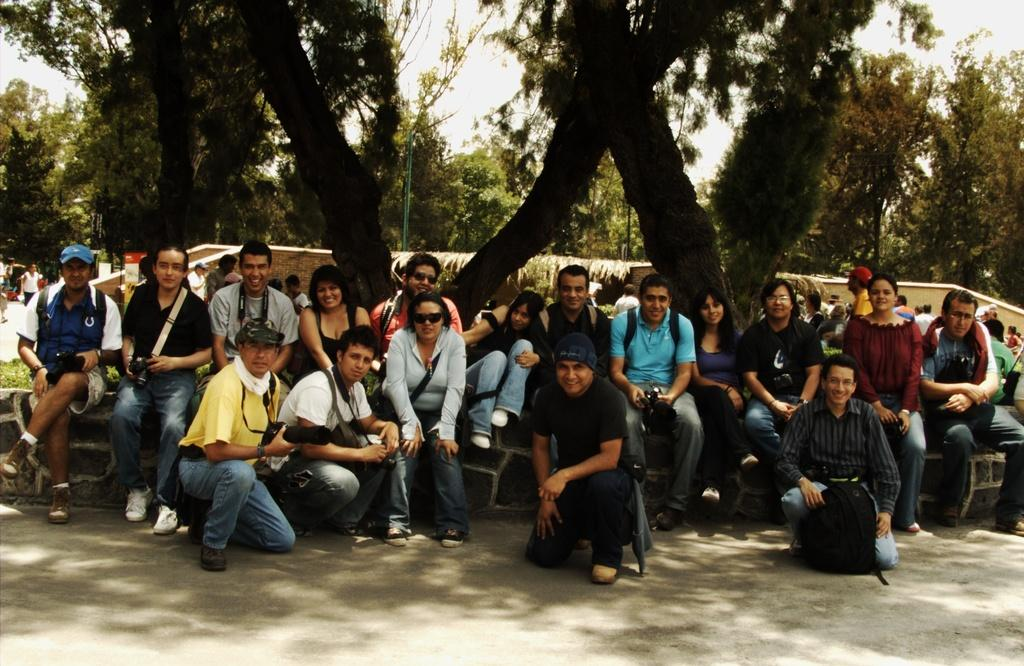How many people are in the image? There is a group of people in the image, but the exact number is not specified. What is the position of the people in the image? The people are on the ground in the image. What can be seen in the background of the image? There are trees, a wall, the sky, and unspecified objects in the background of the image. What language are the mice speaking in the image? There are no mice present in the image, so it is not possible to determine what language they might be speaking. 